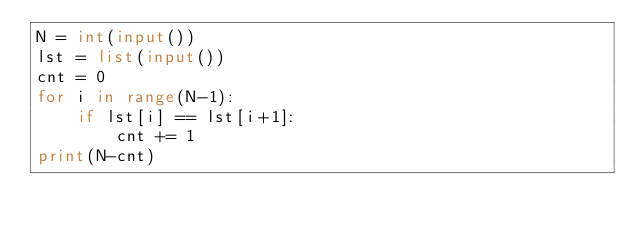Convert code to text. <code><loc_0><loc_0><loc_500><loc_500><_Python_>N = int(input())
lst = list(input())
cnt = 0
for i in range(N-1):
    if lst[i] == lst[i+1]:
        cnt += 1
print(N-cnt)</code> 